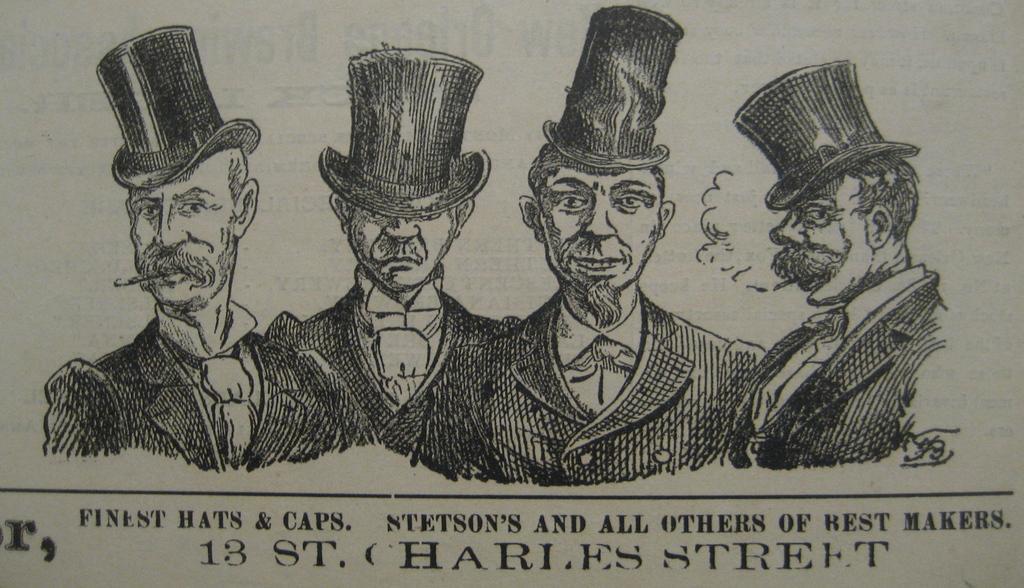Please provide a concise description of this image. In the image I can see the paper on which there are some pictures of people along with the text. 